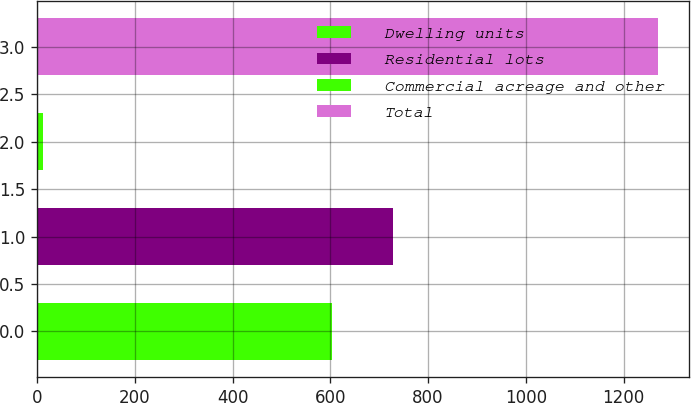Convert chart to OTSL. <chart><loc_0><loc_0><loc_500><loc_500><bar_chart><fcel>Dwelling units<fcel>Residential lots<fcel>Commercial acreage and other<fcel>Total<nl><fcel>603<fcel>728.8<fcel>12<fcel>1270<nl></chart> 